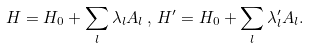<formula> <loc_0><loc_0><loc_500><loc_500>H = H _ { 0 } + \sum _ { l } \lambda _ { l } A _ { l } \, , \, H ^ { \prime } = H _ { 0 } + \sum _ { l } \lambda _ { l } ^ { \prime } A _ { l } .</formula> 